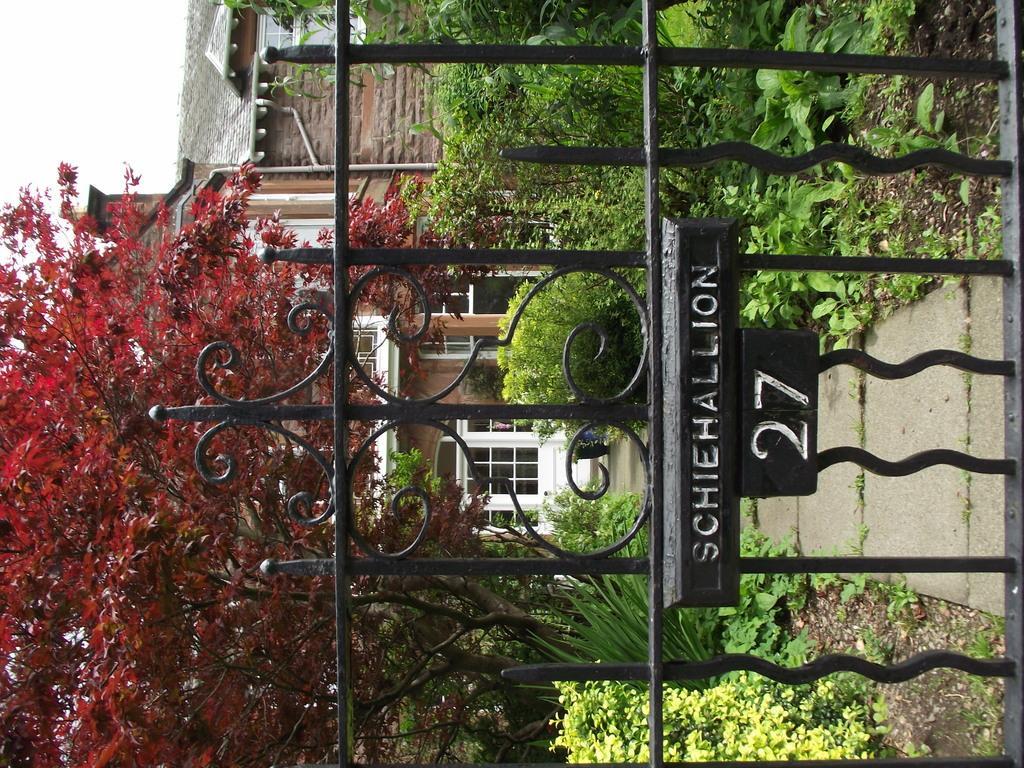Can you describe this image briefly? There is a gate on the right side of this image and there are some trees in the background. There is a building in the middle of this image. As we can see there is a sky at the top left corner of this image. 